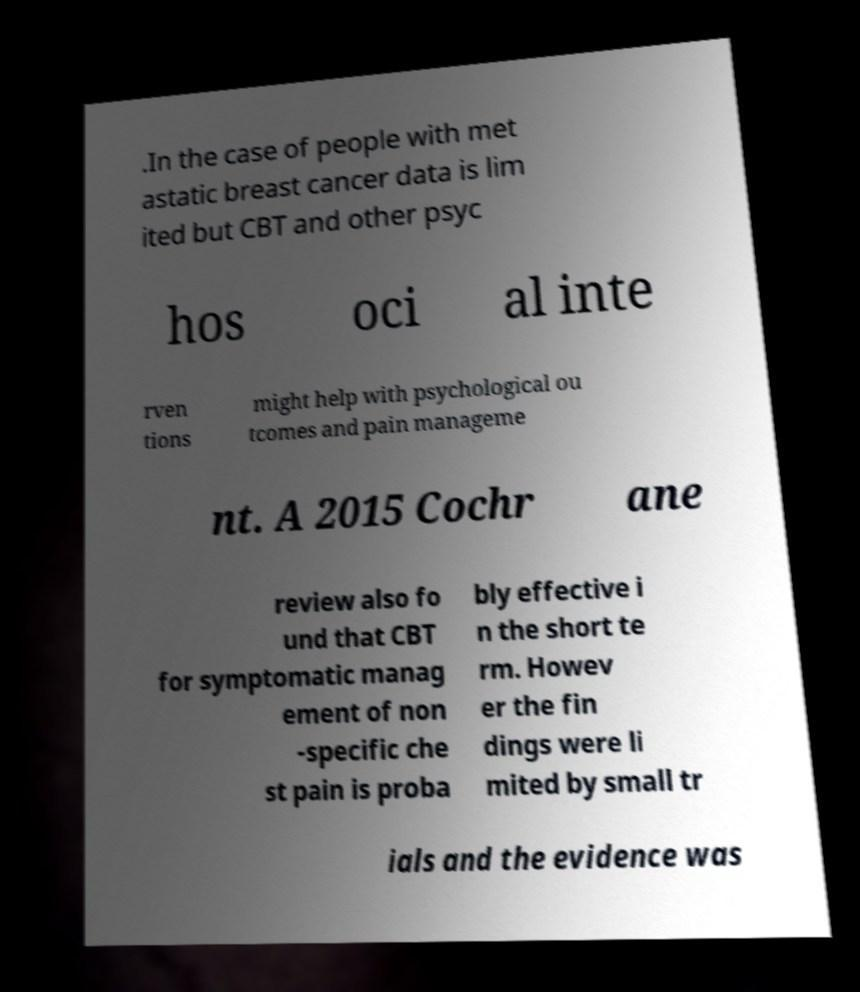I need the written content from this picture converted into text. Can you do that? .In the case of people with met astatic breast cancer data is lim ited but CBT and other psyc hos oci al inte rven tions might help with psychological ou tcomes and pain manageme nt. A 2015 Cochr ane review also fo und that CBT for symptomatic manag ement of non -specific che st pain is proba bly effective i n the short te rm. Howev er the fin dings were li mited by small tr ials and the evidence was 